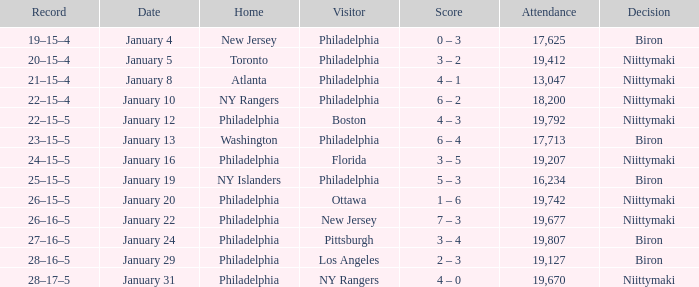Which team was the visitor on January 10? Philadelphia. 